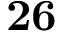Convert formula to latex. <formula><loc_0><loc_0><loc_500><loc_500>2 6</formula> 